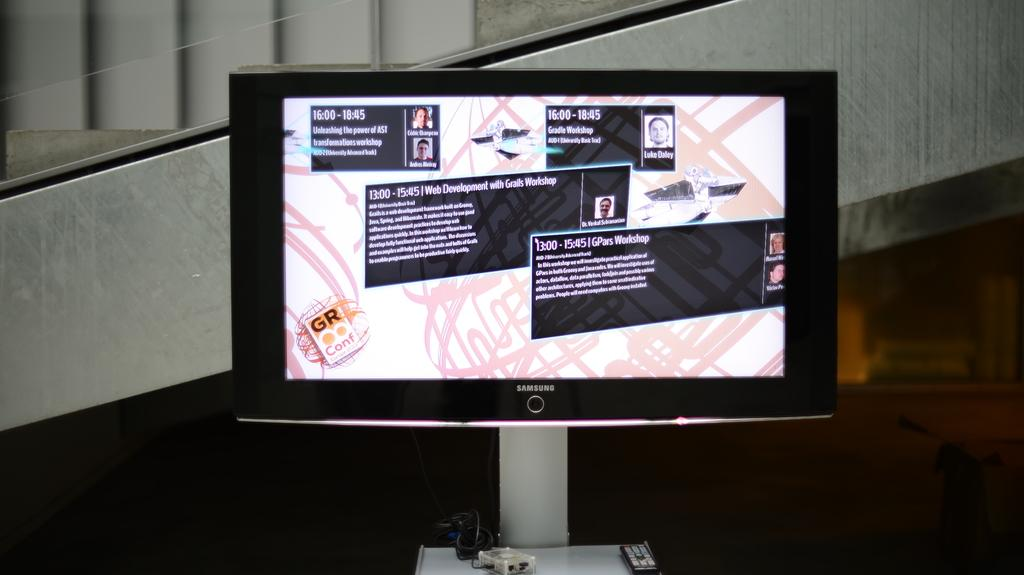<image>
Summarize the visual content of the image. A Samsung computer monitor showing paragraphs of text and photos. 